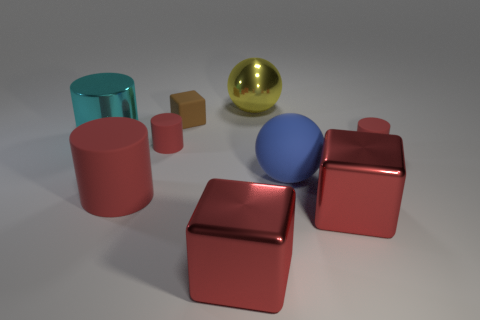Is the color of the shiny sphere the same as the small block?
Give a very brief answer. No. Are there fewer large red shiny blocks that are to the left of the cyan metal thing than large red matte things that are right of the small brown cube?
Provide a succinct answer. No. Do the cyan cylinder and the large yellow object have the same material?
Your response must be concise. Yes. There is a cube that is in front of the brown matte cube and left of the yellow metallic thing; what size is it?
Give a very brief answer. Large. What shape is the rubber thing that is the same size as the matte ball?
Provide a short and direct response. Cylinder. The cylinder that is on the right side of the tiny thing that is behind the metallic thing to the left of the small cube is made of what material?
Provide a succinct answer. Rubber. Does the large shiny object on the right side of the blue thing have the same shape as the small rubber thing that is on the right side of the small block?
Your response must be concise. No. How many other objects are the same material as the yellow ball?
Give a very brief answer. 3. Are the tiny cylinder to the right of the big yellow thing and the sphere in front of the brown object made of the same material?
Your response must be concise. Yes. The tiny brown object that is the same material as the big blue thing is what shape?
Your answer should be very brief. Cube. 